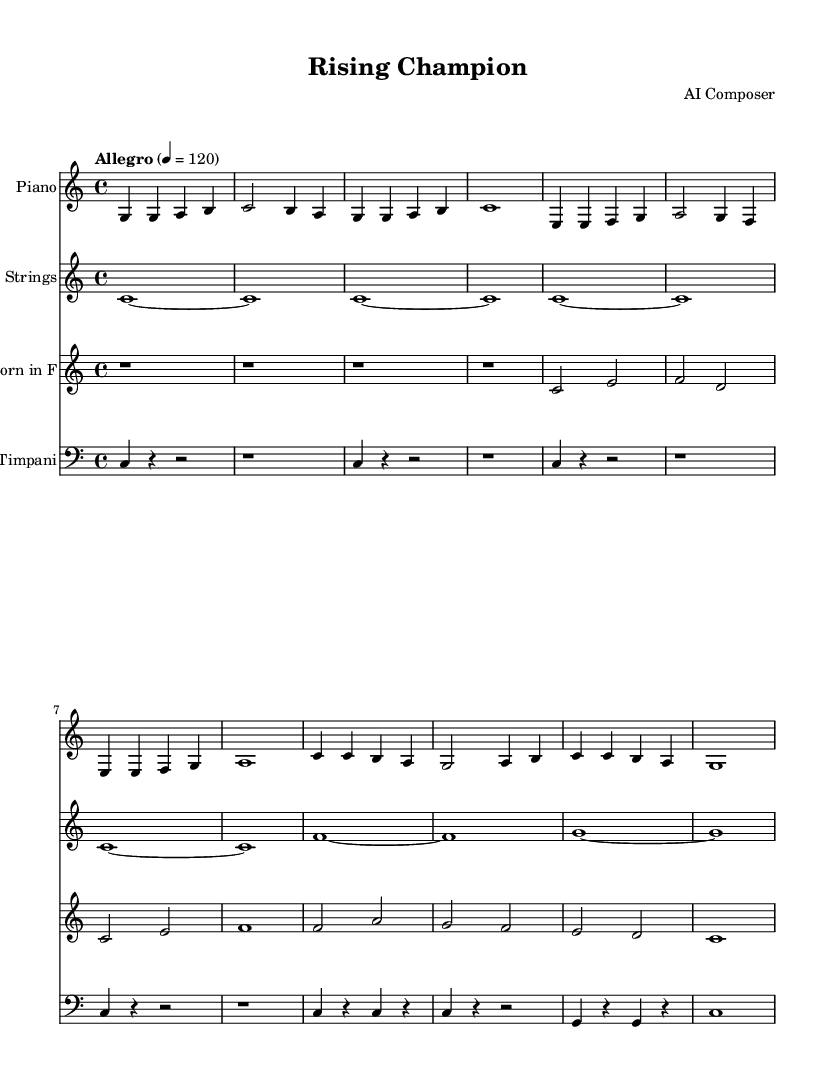What is the key signature of this music? The key signature is indicated at the beginning of the score and shows no sharps or flats, which identifies it as C major.
Answer: C major What is the time signature of the piece? The time signature is found at the beginning of the score and is written as a fraction. It shows that there are four beats in each measure and the quarter note gets one beat, which is indicative of 4/4 time.
Answer: 4/4 What is the tempo marking for this composition? The tempo marking, indicated at the start of the score, states "Allegro" with a metronome marking of 120 beats per minute, which denotes a fast pace.
Answer: Allegro 4 = 120 What instruments are included in the score? The score lists four instruments at the beginning: Piano, Strings, Horn in F, and Timpani. This can be seen in the instrument names on each staff.
Answer: Piano, Strings, Horn in F, Timpani How many measures are in the Intro section of the music? By examining the Intro section, which is marked with comments, we count the measures presented there: there are four measures in total before moving on to the Verse.
Answer: 4 Explain how the Chorus section is structured in terms of measures. The Chorus section can be identified by its specific pattern and structure. It is written as four measures long and consists of two repeating phrases, each having a simple rhythmic pattern that supports its melodic line.
Answer: 4 measures What is the significance of the French Horn part in this score? The French Horn part serves as a harmonic and melodic support, adding richness to the overall sound. The score indicates a simplified version of the part that complements the piano and strings, enhancing the arrangement's inspirational quality.
Answer: Harmonic support 